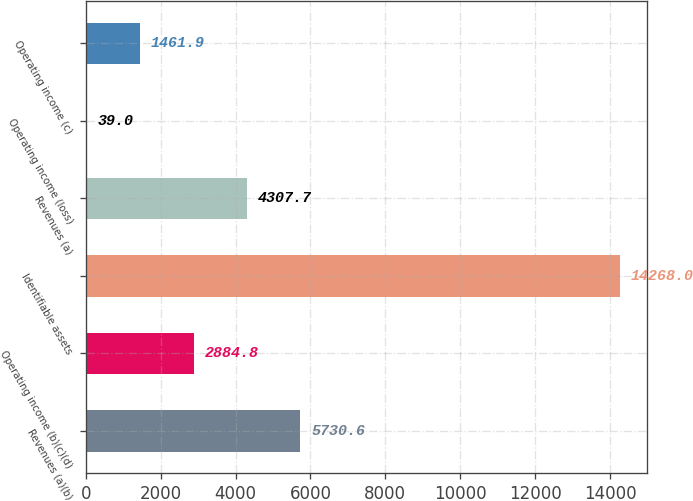Convert chart to OTSL. <chart><loc_0><loc_0><loc_500><loc_500><bar_chart><fcel>Revenues (a)(b)<fcel>Operating income (b)(c)(d)<fcel>Identifiable assets<fcel>Revenues (a)<fcel>Operating income (loss)<fcel>Operating income (c)<nl><fcel>5730.6<fcel>2884.8<fcel>14268<fcel>4307.7<fcel>39<fcel>1461.9<nl></chart> 